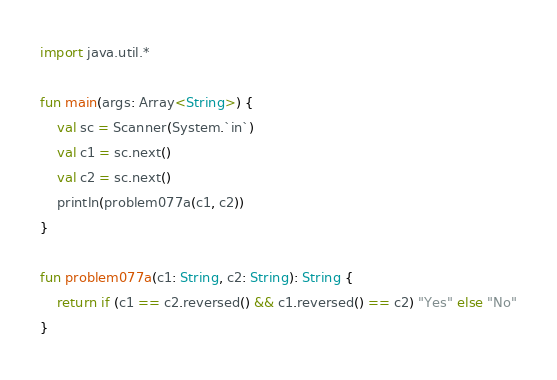Convert code to text. <code><loc_0><loc_0><loc_500><loc_500><_Kotlin_>import java.util.*

fun main(args: Array<String>) {
    val sc = Scanner(System.`in`)
    val c1 = sc.next()
    val c2 = sc.next()
    println(problem077a(c1, c2))
}

fun problem077a(c1: String, c2: String): String {
    return if (c1 == c2.reversed() && c1.reversed() == c2) "Yes" else "No"
}</code> 